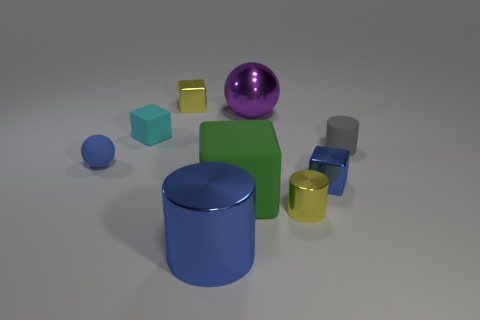Does the big ball have the same color as the metal object that is to the right of the tiny yellow metallic cylinder?
Offer a very short reply. No. Are there any yellow cylinders of the same size as the blue cube?
Offer a very short reply. Yes. What size is the cube that is the same color as the tiny metal cylinder?
Give a very brief answer. Small. What material is the tiny cylinder in front of the tiny blue rubber ball?
Your answer should be very brief. Metal. Is the number of spheres that are left of the shiny ball the same as the number of big things in front of the cyan matte thing?
Your answer should be compact. No. There is a metallic cube that is in front of the small cyan matte thing; is its size the same as the yellow shiny object that is on the left side of the small shiny cylinder?
Provide a succinct answer. Yes. How many metal objects are the same color as the big ball?
Keep it short and to the point. 0. There is a ball that is the same color as the large metallic cylinder; what is its material?
Ensure brevity in your answer.  Rubber. Is the number of tiny yellow metallic things in front of the small yellow cube greater than the number of tiny gray things?
Offer a terse response. No. Is the shape of the large green object the same as the small blue rubber thing?
Your response must be concise. No. 